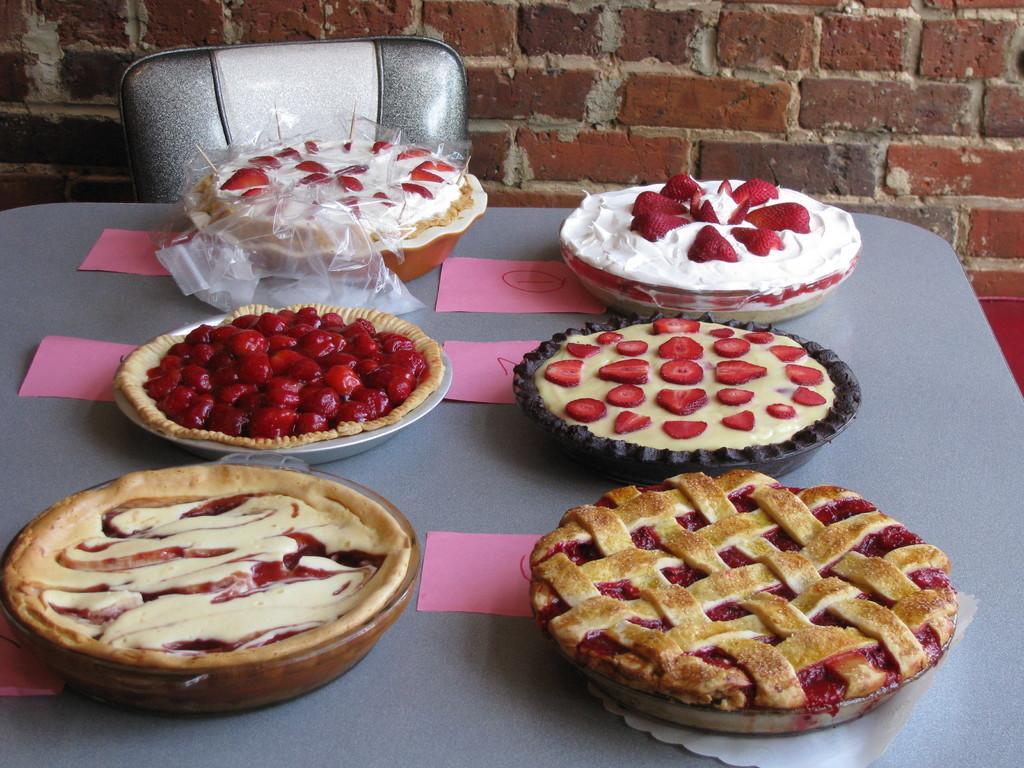In one or two sentences, can you explain what this image depicts? In this image we can see different food items kept on the pans which are placed on the table. Here we can see pink color papers are also kept on the table, we can see a chair and the brick wall in the background. 